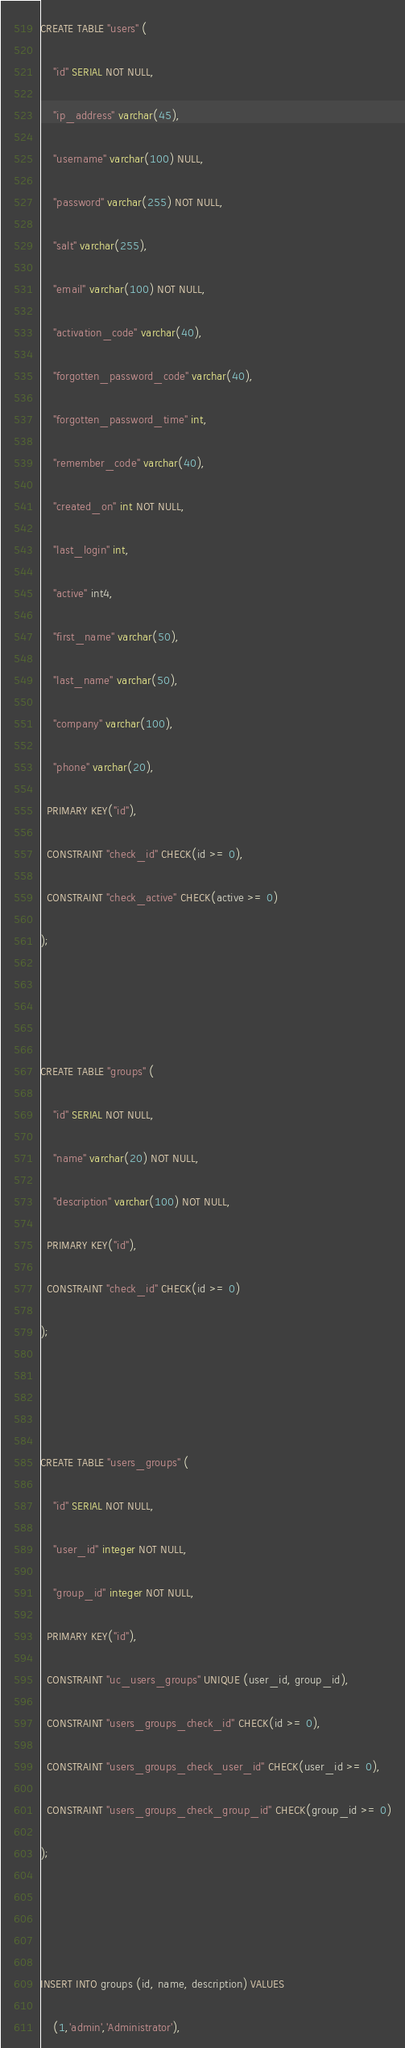<code> <loc_0><loc_0><loc_500><loc_500><_SQL_>CREATE TABLE "users" (
    "id" SERIAL NOT NULL,
    "ip_address" varchar(45),
    "username" varchar(100) NULL,
    "password" varchar(255) NOT NULL,
    "salt" varchar(255),
    "email" varchar(100) NOT NULL,
    "activation_code" varchar(40),
    "forgotten_password_code" varchar(40),
    "forgotten_password_time" int,
    "remember_code" varchar(40),
    "created_on" int NOT NULL,
    "last_login" int,
    "active" int4,
    "first_name" varchar(50),
    "last_name" varchar(50),
    "company" varchar(100),
    "phone" varchar(20),
  PRIMARY KEY("id"),
  CONSTRAINT "check_id" CHECK(id >= 0),
  CONSTRAINT "check_active" CHECK(active >= 0)
);


CREATE TABLE "groups" (
    "id" SERIAL NOT NULL,
    "name" varchar(20) NOT NULL,
    "description" varchar(100) NOT NULL,
  PRIMARY KEY("id"),
  CONSTRAINT "check_id" CHECK(id >= 0)
);


CREATE TABLE "users_groups" (
    "id" SERIAL NOT NULL,
    "user_id" integer NOT NULL,
    "group_id" integer NOT NULL,
  PRIMARY KEY("id"),
  CONSTRAINT "uc_users_groups" UNIQUE (user_id, group_id),
  CONSTRAINT "users_groups_check_id" CHECK(id >= 0),
  CONSTRAINT "users_groups_check_user_id" CHECK(user_id >= 0),
  CONSTRAINT "users_groups_check_group_id" CHECK(group_id >= 0)
);


INSERT INTO groups (id, name, description) VALUES
    (1,'admin','Administrator'),</code> 